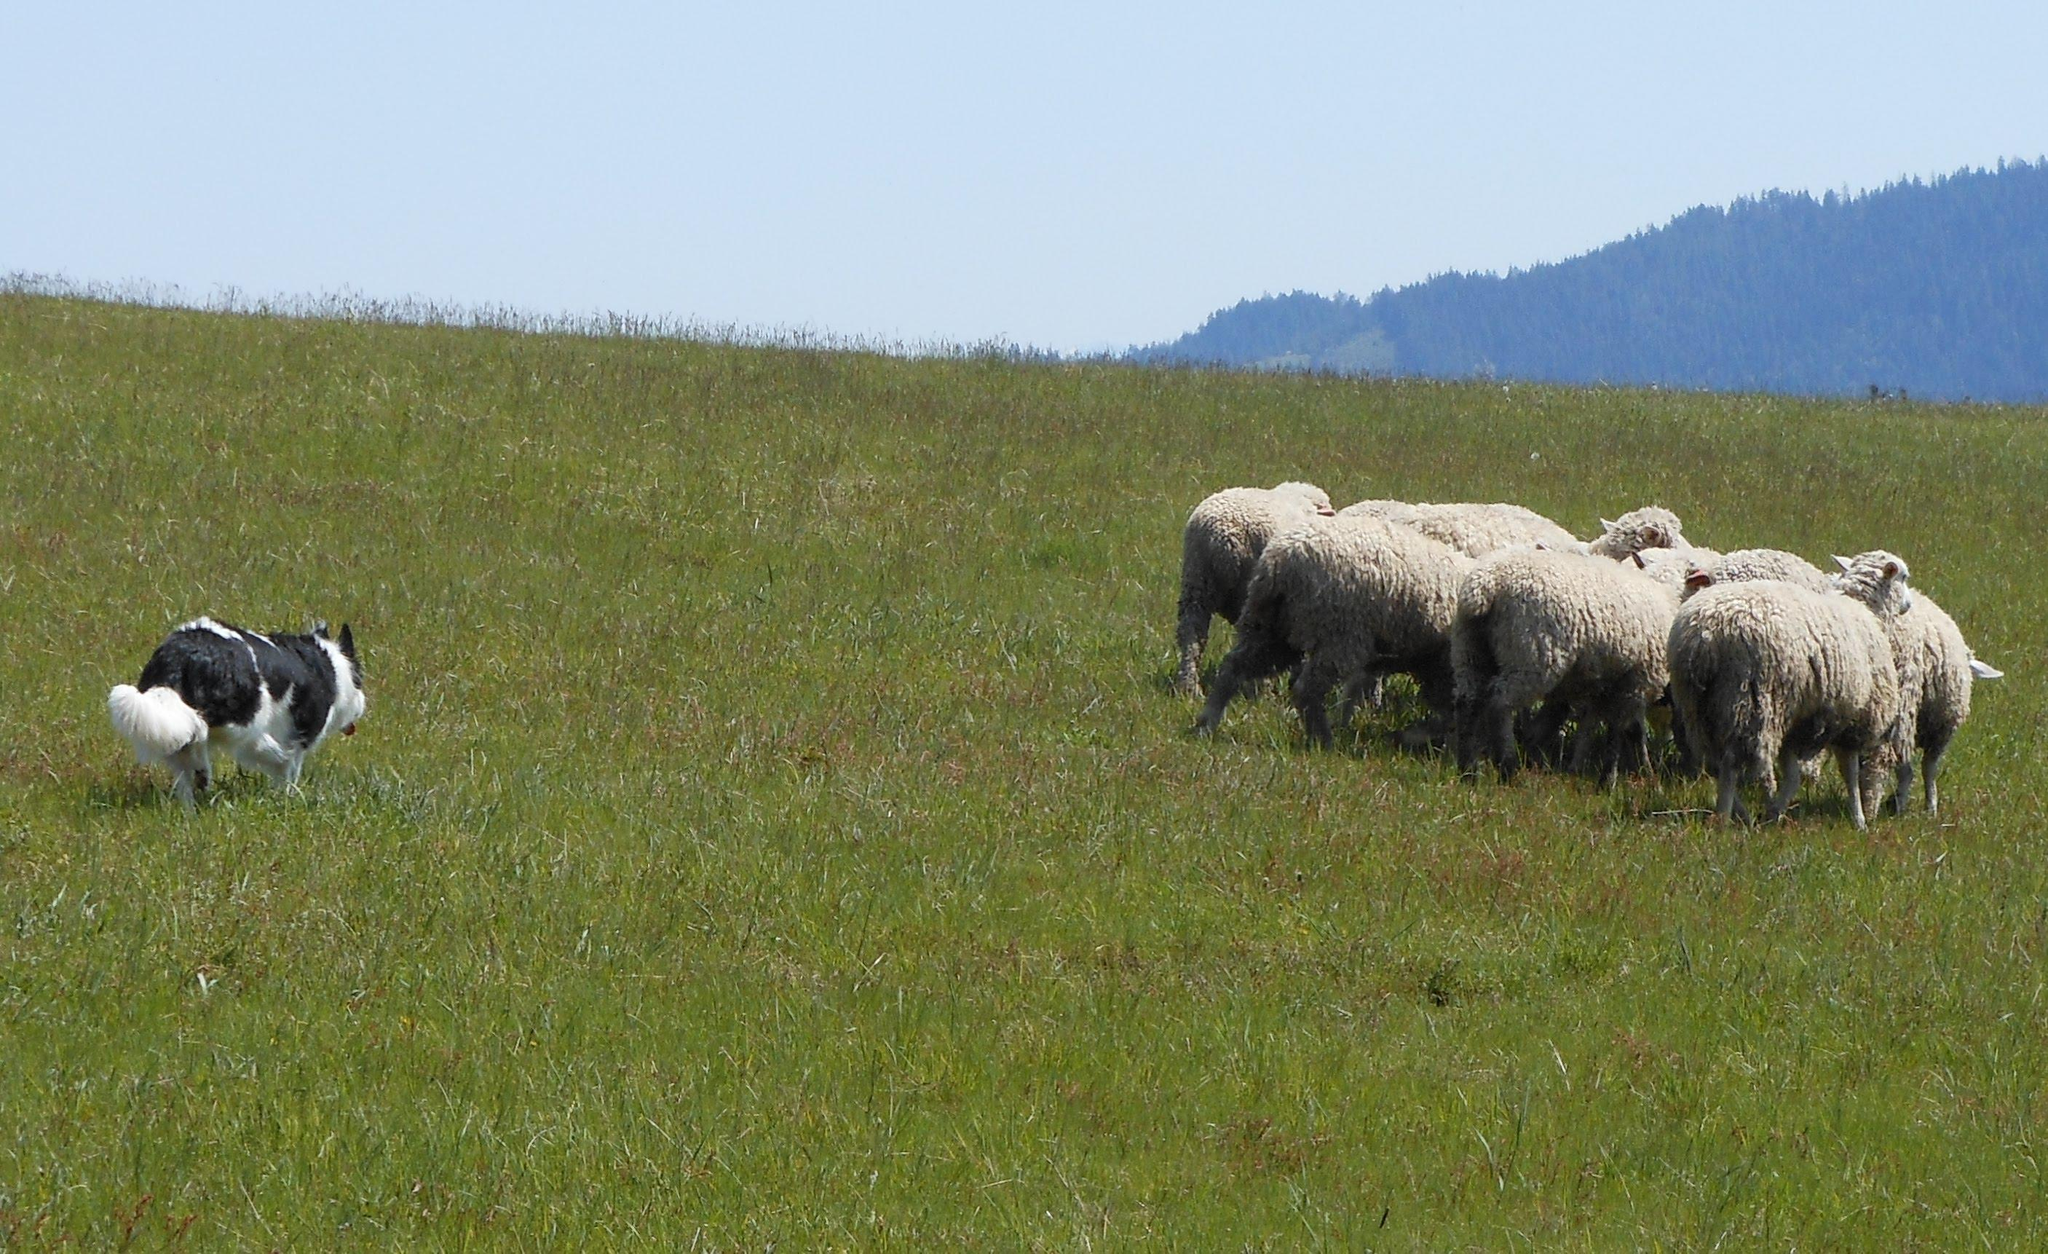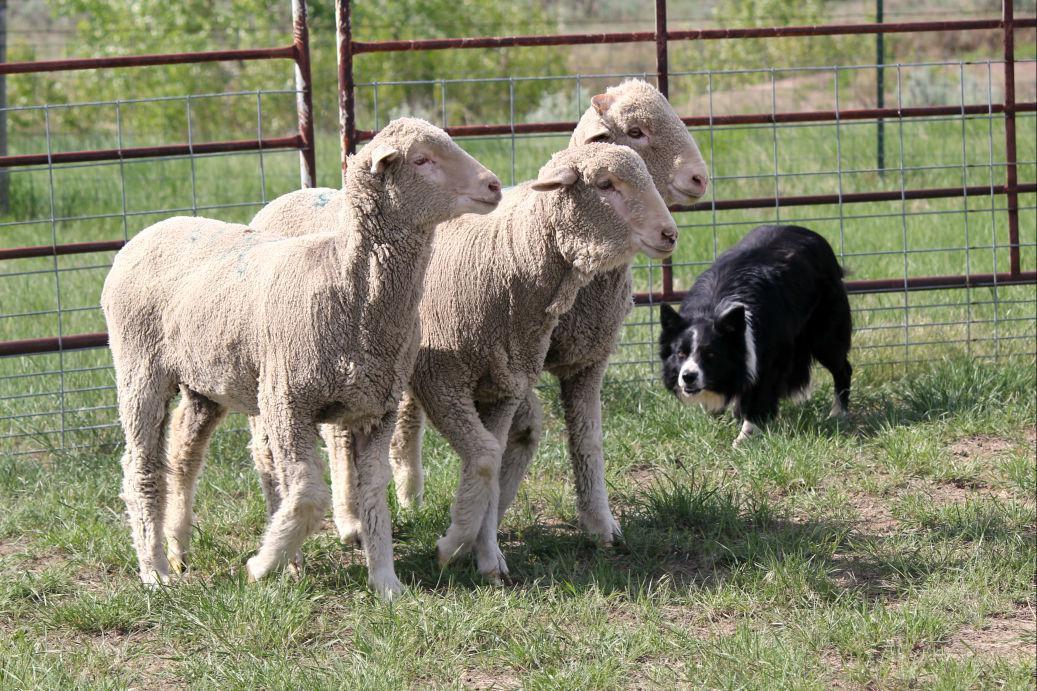The first image is the image on the left, the second image is the image on the right. For the images shown, is this caption "The dog in the image on the left is moving toward the camera." true? Answer yes or no. No. The first image is the image on the left, the second image is the image on the right. Evaluate the accuracy of this statement regarding the images: "One image focuses on the dog close to one sheep.". Is it true? Answer yes or no. No. 